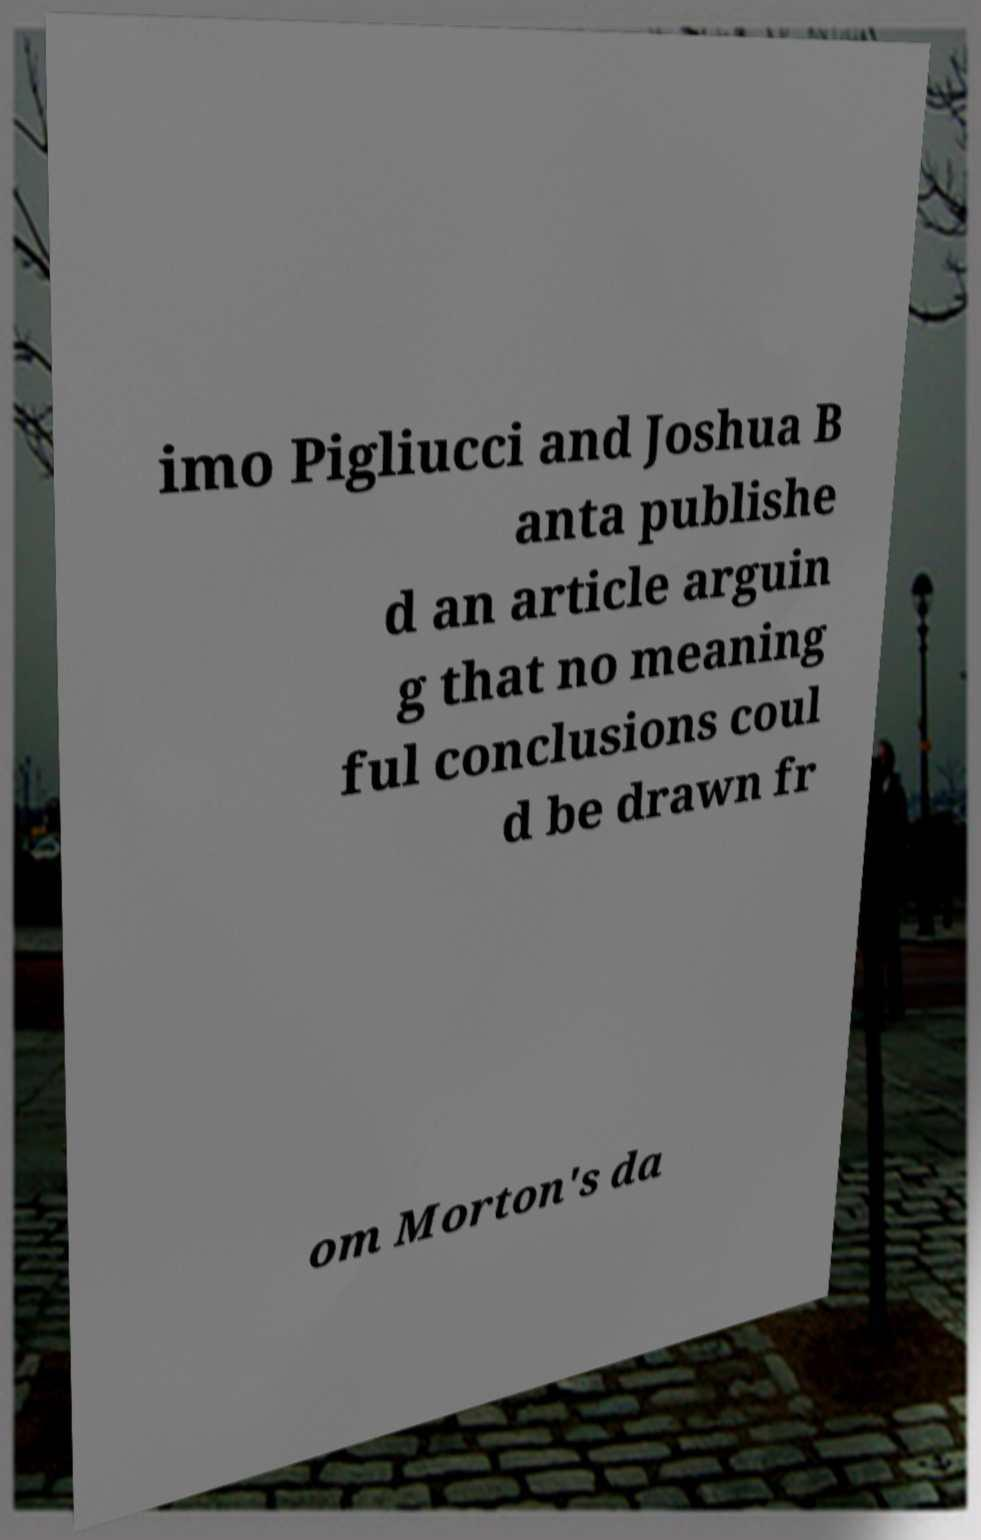Please identify and transcribe the text found in this image. imo Pigliucci and Joshua B anta publishe d an article arguin g that no meaning ful conclusions coul d be drawn fr om Morton's da 